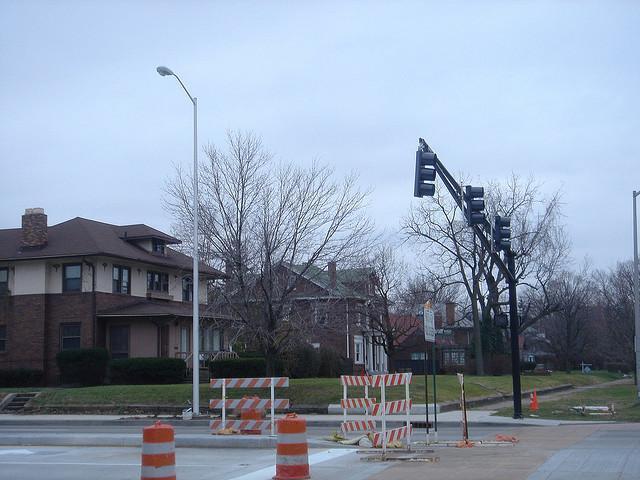How many orange barrels do you see?
Give a very brief answer. 2. How many flags?
Give a very brief answer. 0. How many barricades are shown?
Give a very brief answer. 3. 